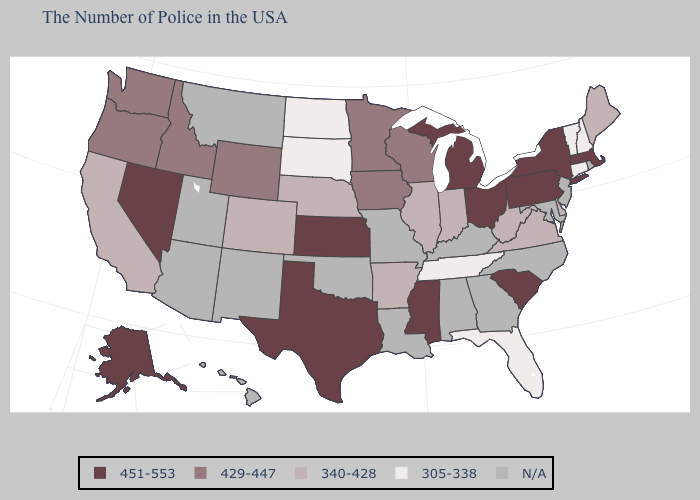Which states have the lowest value in the Northeast?
Short answer required. New Hampshire, Vermont, Connecticut. Does the map have missing data?
Be succinct. Yes. What is the value of Illinois?
Answer briefly. 340-428. What is the value of Tennessee?
Quick response, please. 305-338. What is the value of South Carolina?
Concise answer only. 451-553. Name the states that have a value in the range 429-447?
Keep it brief. Wisconsin, Minnesota, Iowa, Wyoming, Idaho, Washington, Oregon. What is the value of Virginia?
Answer briefly. 340-428. Among the states that border West Virginia , does Ohio have the lowest value?
Give a very brief answer. No. Name the states that have a value in the range 429-447?
Be succinct. Wisconsin, Minnesota, Iowa, Wyoming, Idaho, Washington, Oregon. Among the states that border Colorado , does Nebraska have the highest value?
Write a very short answer. No. Name the states that have a value in the range N/A?
Answer briefly. Rhode Island, New Jersey, Maryland, North Carolina, Georgia, Kentucky, Alabama, Louisiana, Missouri, Oklahoma, New Mexico, Utah, Montana, Arizona, Hawaii. Does Massachusetts have the highest value in the USA?
Write a very short answer. Yes. Name the states that have a value in the range 305-338?
Answer briefly. New Hampshire, Vermont, Connecticut, Florida, Tennessee, South Dakota, North Dakota. What is the lowest value in states that border New York?
Keep it brief. 305-338. 